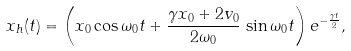<formula> <loc_0><loc_0><loc_500><loc_500>x _ { h } ( t ) = \left ( x _ { 0 } \cos \omega _ { 0 } t + \frac { \gamma x _ { 0 } + 2 v _ { 0 } } { 2 \omega _ { 0 } } \, \sin \omega _ { 0 } t \right ) e ^ { - \frac { \gamma t } { 2 } } ,</formula> 